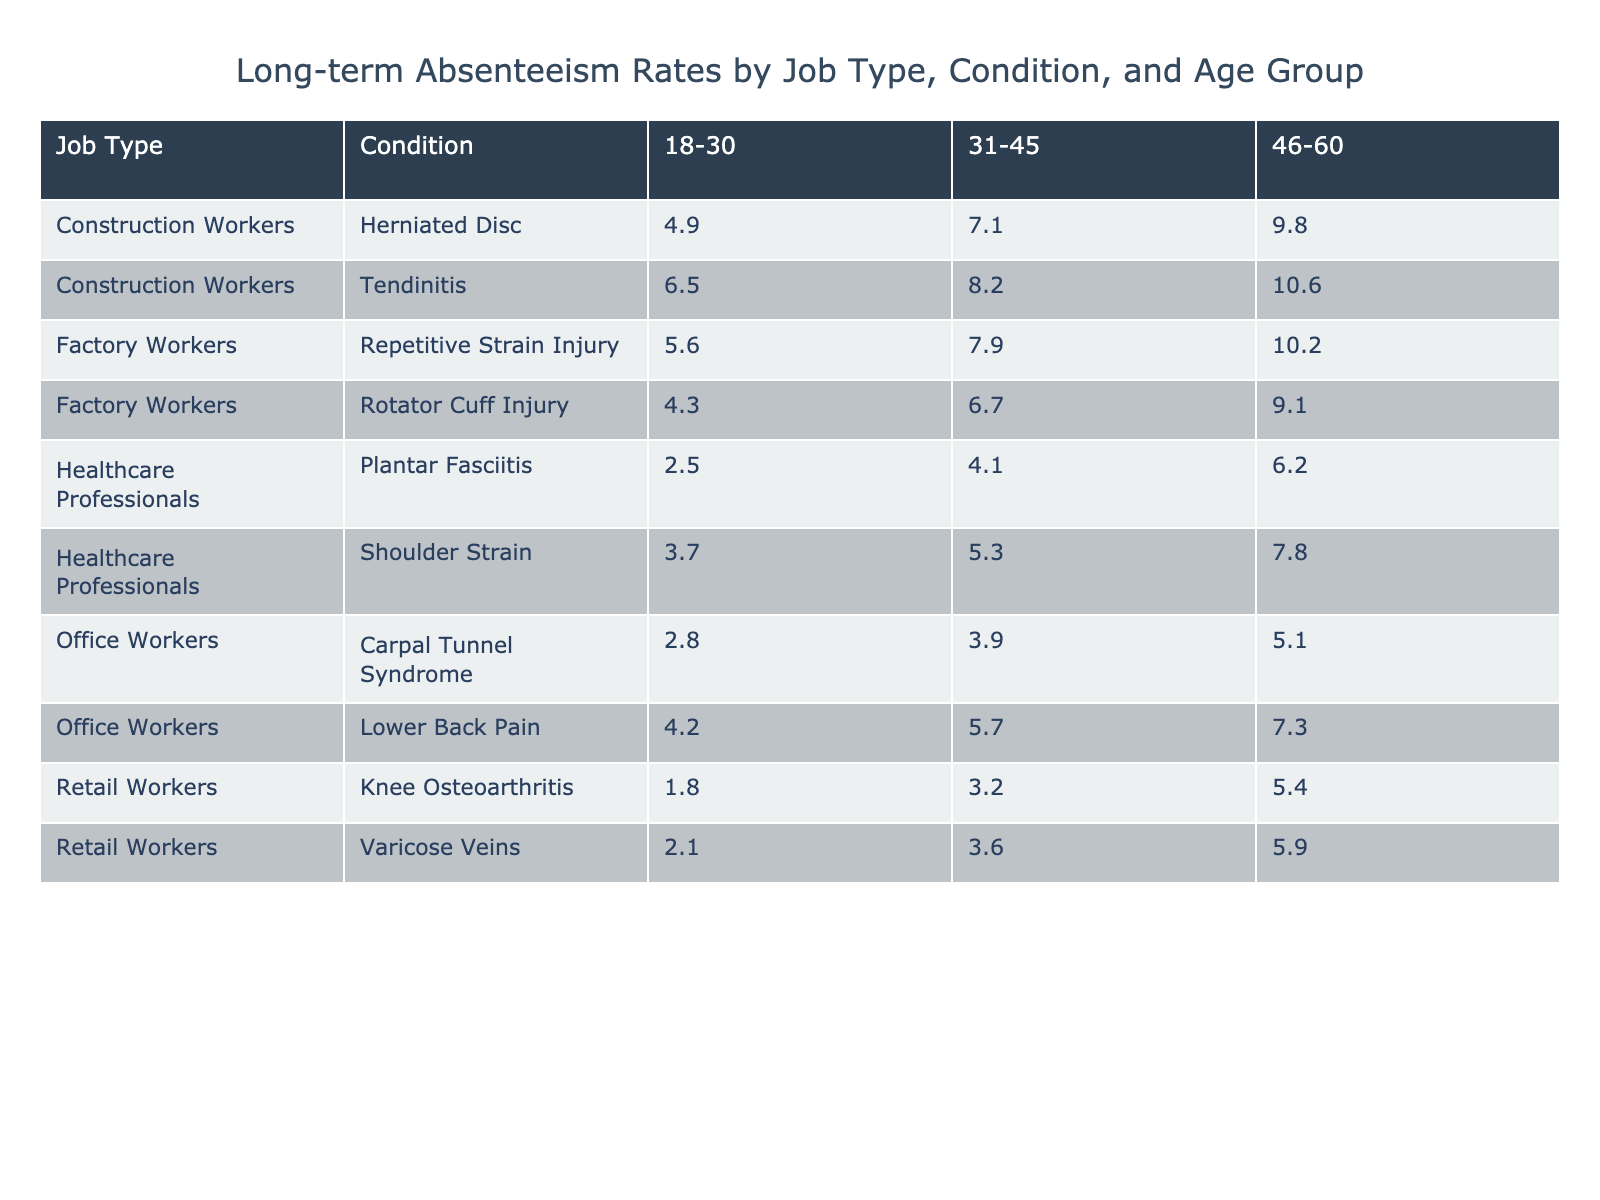What is the absenteeism rate for Office Workers aged 46-60 due to Lower Back Pain? The table shows that for Office Workers in the age group 46-60, the absenteeism rate for Lower Back Pain is 7.3%.
Answer: 7.3% Which job type has the highest absenteeism rate for the age group 31-45? By examining the absenteeism rates for each job type in the 31-45 age group, Construction Workers have the highest rate of 8.2% for Tendinitis.
Answer: Construction Workers What is the average absenteeism rate for Healthcare Professionals aged 18-30? The absenteeism rates for Healthcare Professionals aged 18-30 are 3.7% (Shoulder Strain) and 2.5% (Plantar Fasciitis). Summing these rates gives 3.7 + 2.5 = 6.2%. Dividing by the number of data points (2) gives an average of 6.2% / 2 = 3.1%.
Answer: 3.1% Is there any job type in the table that has an absenteeism rate below 3% for any age group? By reviewing the table, it is evident that all reported absenteeism rates are above 3%, as the lowest rate noted is 2.1% for Retail Workers aged 18-30 for Varicose Veins, which is not below 3%.
Answer: No Which condition leads to the highest absenteeism rate for Factory Workers aged 46-60? In the table, for Factory Workers aged 46-60, the absenteeism rates are 10.2% for Repetitive Strain Injury and 9.1% for Rotator Cuff Injury. Thus, 10.2% is the highest rate.
Answer: Repetitive Strain Injury What is the difference in absenteeism rates for Construction Workers between the age groups 18-30 and 46-60 due to Herniated Disc? The absenteeism rate for Construction Workers aged 18-30 due to Herniated Disc is 4.9%, while for the age group 46-60 it is 9.8%. The difference is calculated as 9.8% - 4.9% = 4.9%.
Answer: 4.9% Are there any conditions that have the same absenteeism rate for both the 31-45 and 46-60 age groups among Office Workers? Checking the rates, for Office Workers, the absenteeism rates for Lower Back Pain are 5.7% in the 31-45 group and 7.3% in the 46-60 group; for Carpal Tunnel Syndrome, they are 3.9% and 5.1%, respectively. No conditions have the same rates across those age groups.
Answer: No Which job type has the lowest absenteeism rate for the 18-30 age group? Reviewing the table for the 18-30 age group, Retail Workers have the lowest absenteeism rate of 1.8% for Knee Osteoarthritis.
Answer: Retail Workers What is the total absenteeism rate for Construction Workers across all age groups? The absenteeism rates for Construction Workers are 6.5%, 8.2%, 10.6% for age groups 18-30, 31-45, and 46-60 respectively. Summing these gives 6.5 + 8.2 + 10.6 = 25.3%.
Answer: 25.3% Which age group experiences the highest absenteeism rates due to Shoulder Strain across all job types? By checking the table, we find that the highest absenteeism rate due to Shoulder Strain is 7.8% for Healthcare Professionals in the 46-60 age group, higher than that of the 31-45 group at 5.3% for the same condition.
Answer: 46-60 